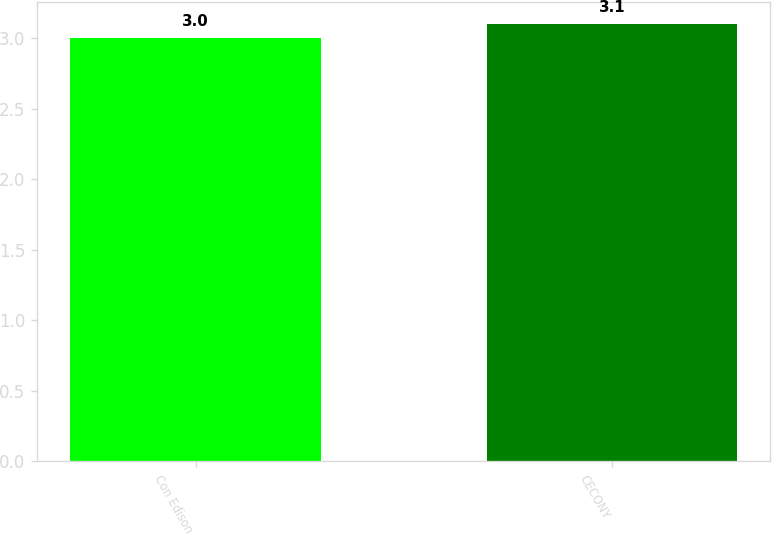Convert chart. <chart><loc_0><loc_0><loc_500><loc_500><bar_chart><fcel>Con Edison<fcel>CECONY<nl><fcel>3<fcel>3.1<nl></chart> 